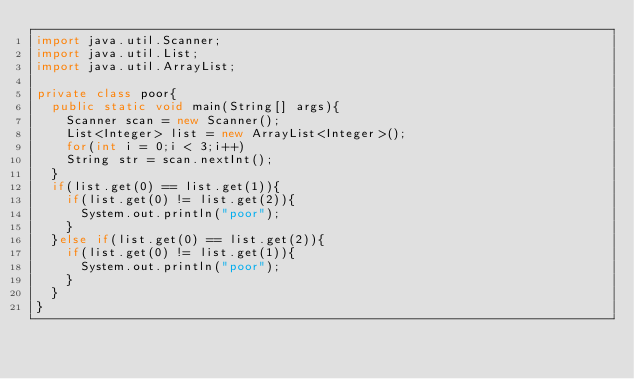Convert code to text. <code><loc_0><loc_0><loc_500><loc_500><_Java_>import java.util.Scanner;
import java.util.List;
import java.util.ArrayList;

private class poor{
  public static void main(String[] args){
    Scanner scan = new Scanner();
    List<Integer> list = new ArrayList<Integer>();
    for(int i = 0;i < 3;i++)
    String str = scan.nextInt();
  }
  if(list.get(0) == list.get(1)){
   	if(list.get(0) != list.get(2)){
      System.out.println("poor");
    }
  }else if(list.get(0) == list.get(2)){
    if(list.get(0) != list.get(1)){
      System.out.println("poor");
    }
  }
}</code> 